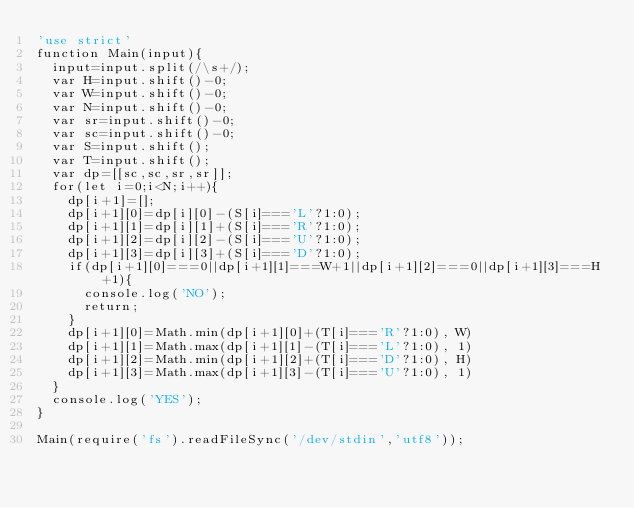<code> <loc_0><loc_0><loc_500><loc_500><_JavaScript_>'use strict'
function Main(input){
  input=input.split(/\s+/);
  var H=input.shift()-0;
  var W=input.shift()-0;
  var N=input.shift()-0;
  var sr=input.shift()-0;
  var sc=input.shift()-0;
  var S=input.shift();
  var T=input.shift();
  var dp=[[sc,sc,sr,sr]];
  for(let i=0;i<N;i++){
    dp[i+1]=[];
    dp[i+1][0]=dp[i][0]-(S[i]==='L'?1:0);
    dp[i+1][1]=dp[i][1]+(S[i]==='R'?1:0);
    dp[i+1][2]=dp[i][2]-(S[i]==='U'?1:0);
    dp[i+1][3]=dp[i][3]+(S[i]==='D'?1:0);
    if(dp[i+1][0]===0||dp[i+1][1]===W+1||dp[i+1][2]===0||dp[i+1][3]===H+1){
      console.log('NO');
      return;
    }
    dp[i+1][0]=Math.min(dp[i+1][0]+(T[i]==='R'?1:0), W)
    dp[i+1][1]=Math.max(dp[i+1][1]-(T[i]==='L'?1:0), 1)
    dp[i+1][2]=Math.min(dp[i+1][2]+(T[i]==='D'?1:0), H)
    dp[i+1][3]=Math.max(dp[i+1][3]-(T[i]==='U'?1:0), 1)
  }
  console.log('YES');
}

Main(require('fs').readFileSync('/dev/stdin','utf8'));
</code> 